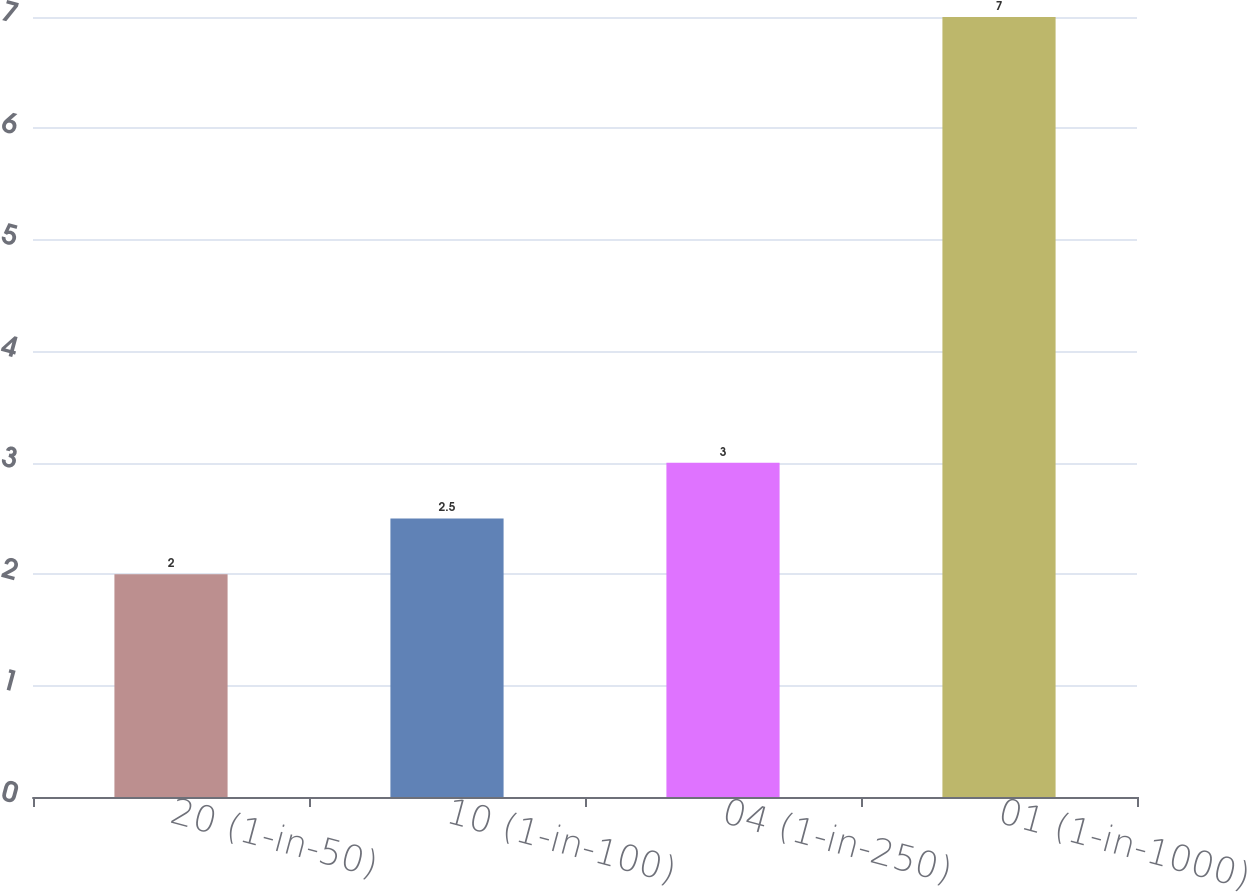Convert chart to OTSL. <chart><loc_0><loc_0><loc_500><loc_500><bar_chart><fcel>20 (1-in-50)<fcel>10 (1-in-100)<fcel>04 (1-in-250)<fcel>01 (1-in-1000)<nl><fcel>2<fcel>2.5<fcel>3<fcel>7<nl></chart> 